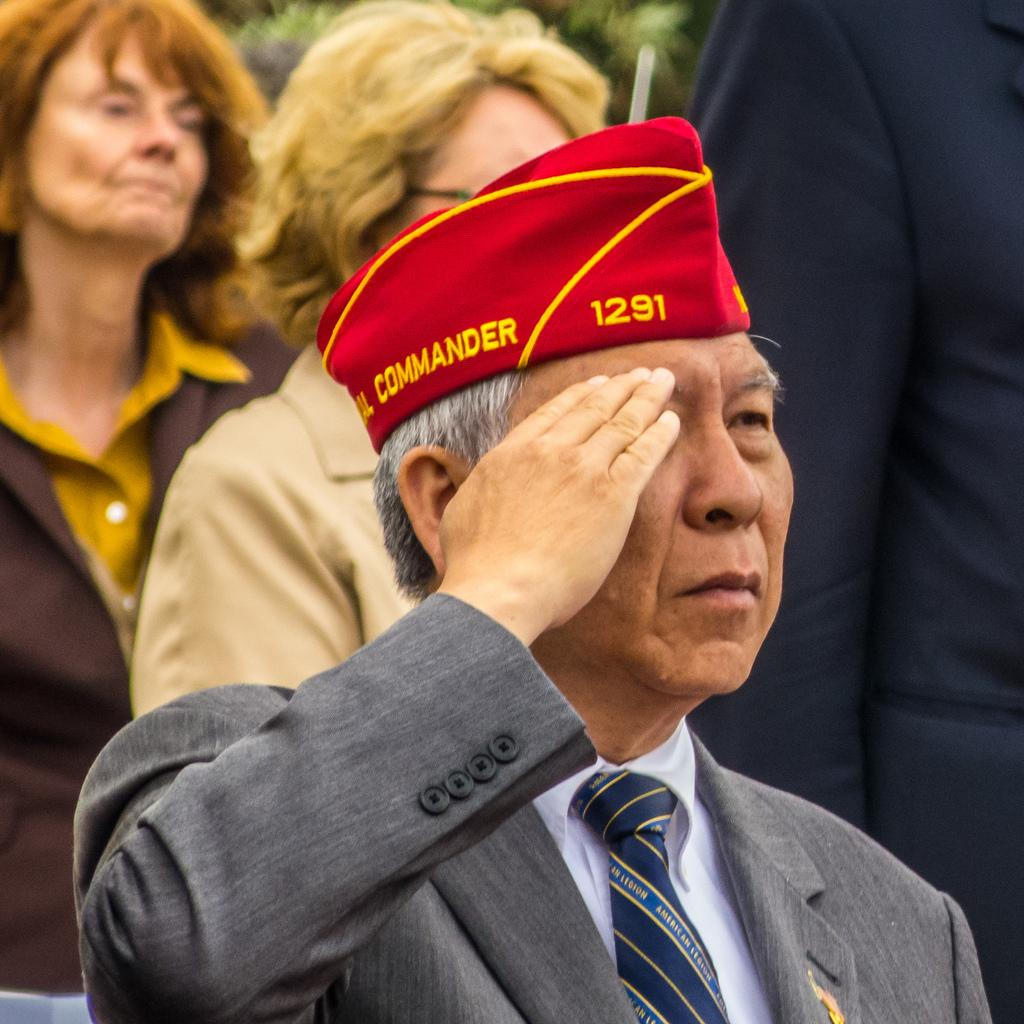How many people are in the image? There are four people in the image. Can you describe the appearance of one of the people? One person in the front is wearing a cap. What can be said about the background of the image? The background of the image is blurry. What type of pear is mentioned in the image? There is no mention of a pear in the image, as it is a visual representation and not a text-based medium. 